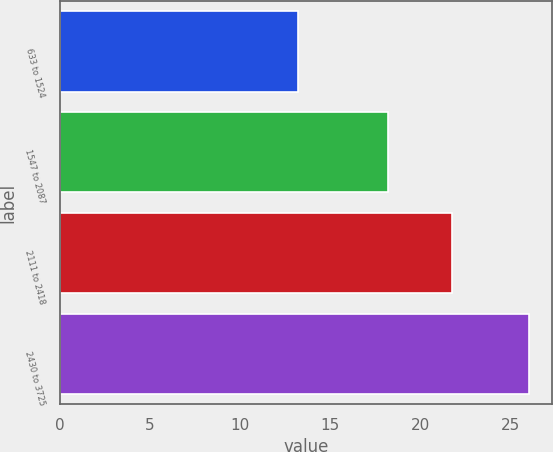Convert chart. <chart><loc_0><loc_0><loc_500><loc_500><bar_chart><fcel>633 to 1524<fcel>1547 to 2087<fcel>2111 to 2418<fcel>2430 to 3725<nl><fcel>13.22<fcel>18.17<fcel>21.75<fcel>25.98<nl></chart> 